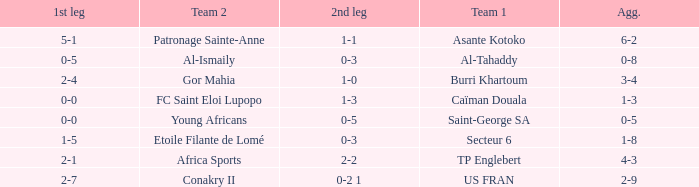Which teams had an aggregate score of 3-4? Burri Khartoum. 